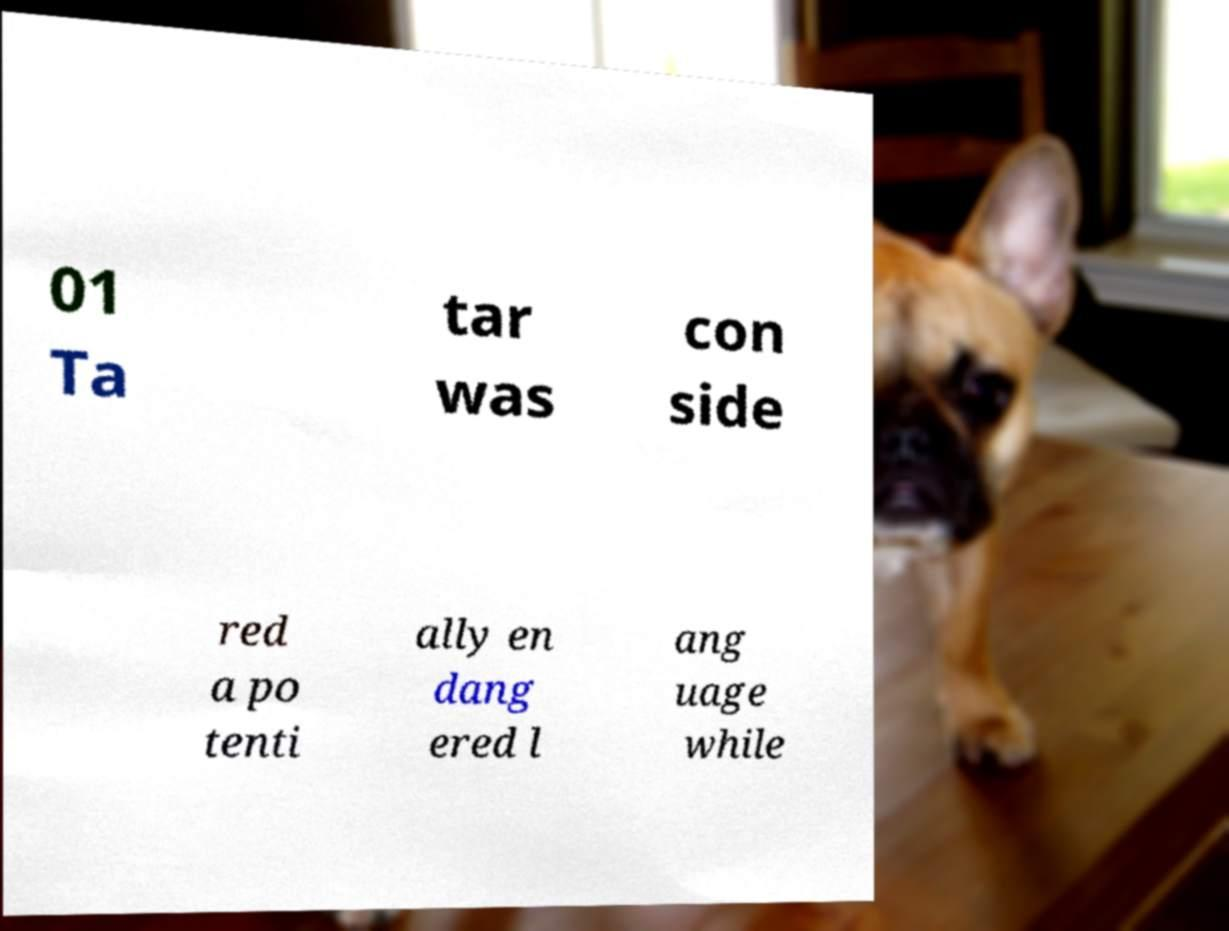There's text embedded in this image that I need extracted. Can you transcribe it verbatim? 01 Ta tar was con side red a po tenti ally en dang ered l ang uage while 